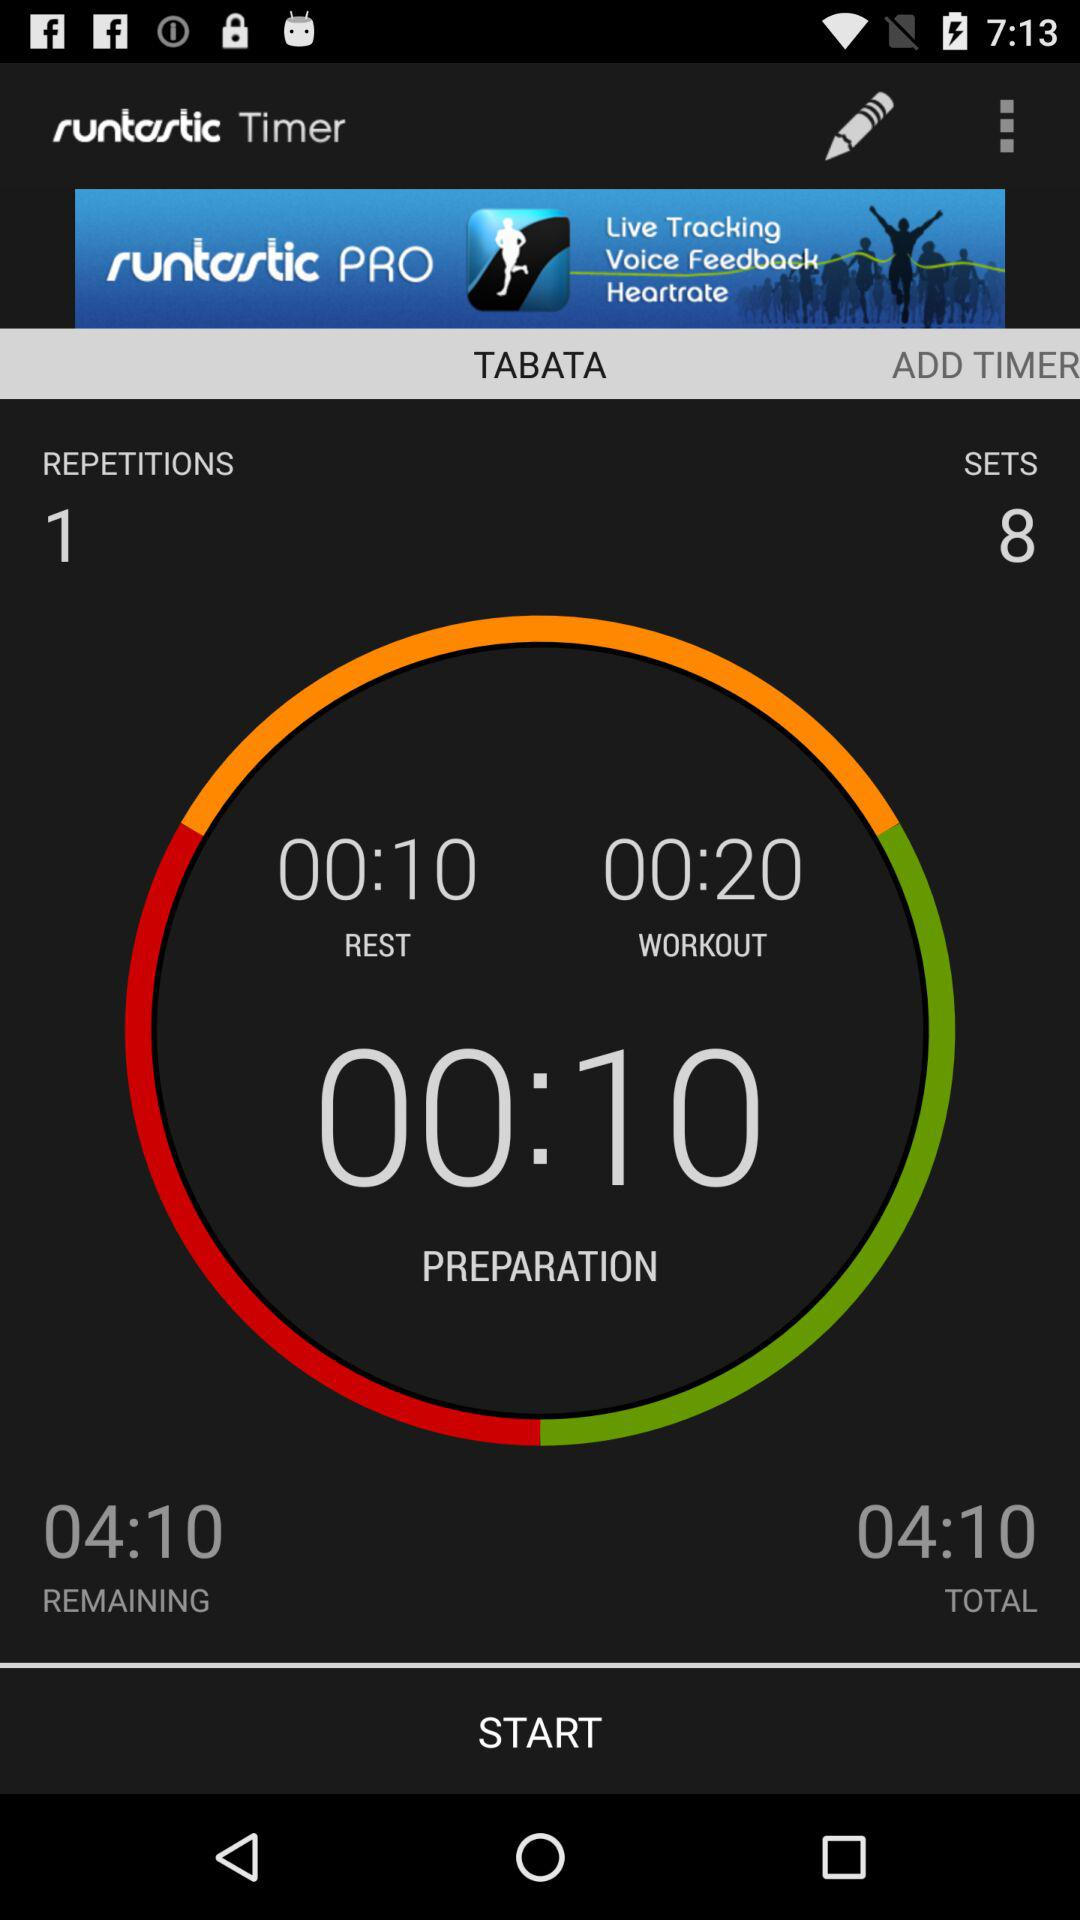What is the workout time? The workout time is 20 seconds. 